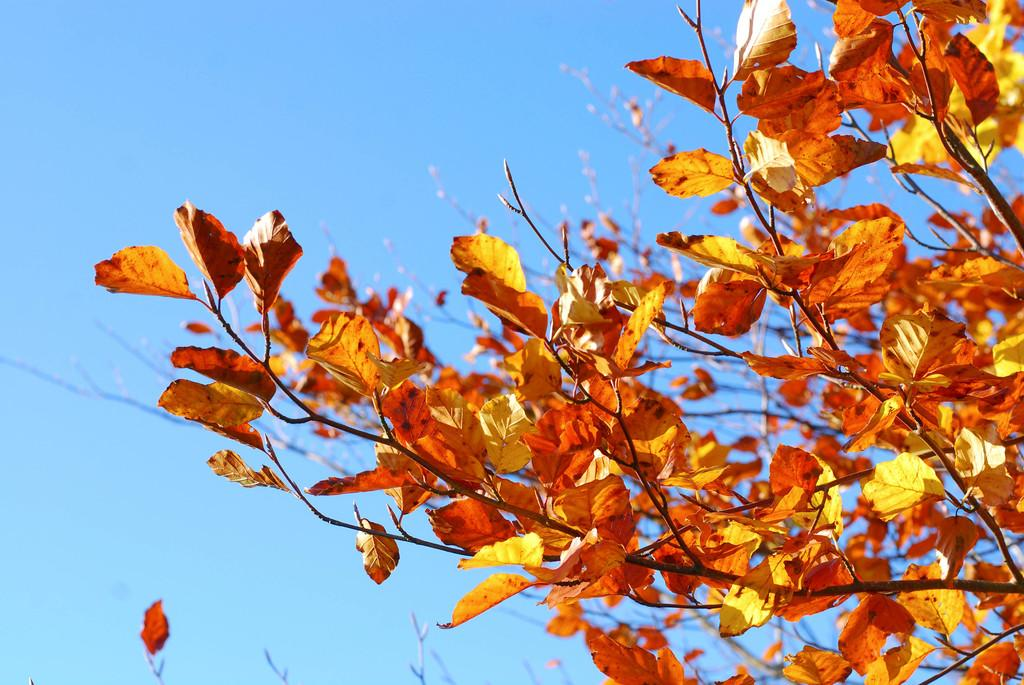What is the main subject of the picture? The main subject of the picture is a tree. What can be observed about the tree's appearance? The tree has many leaves on its branches. What is visible at the top of the picture? The sky is visible at the top of the picture. What is the opinion of the tree about the base of the mountain in the image? There is no mountain or opinion present in the image, as it features a tree with leaves and a visible sky. 